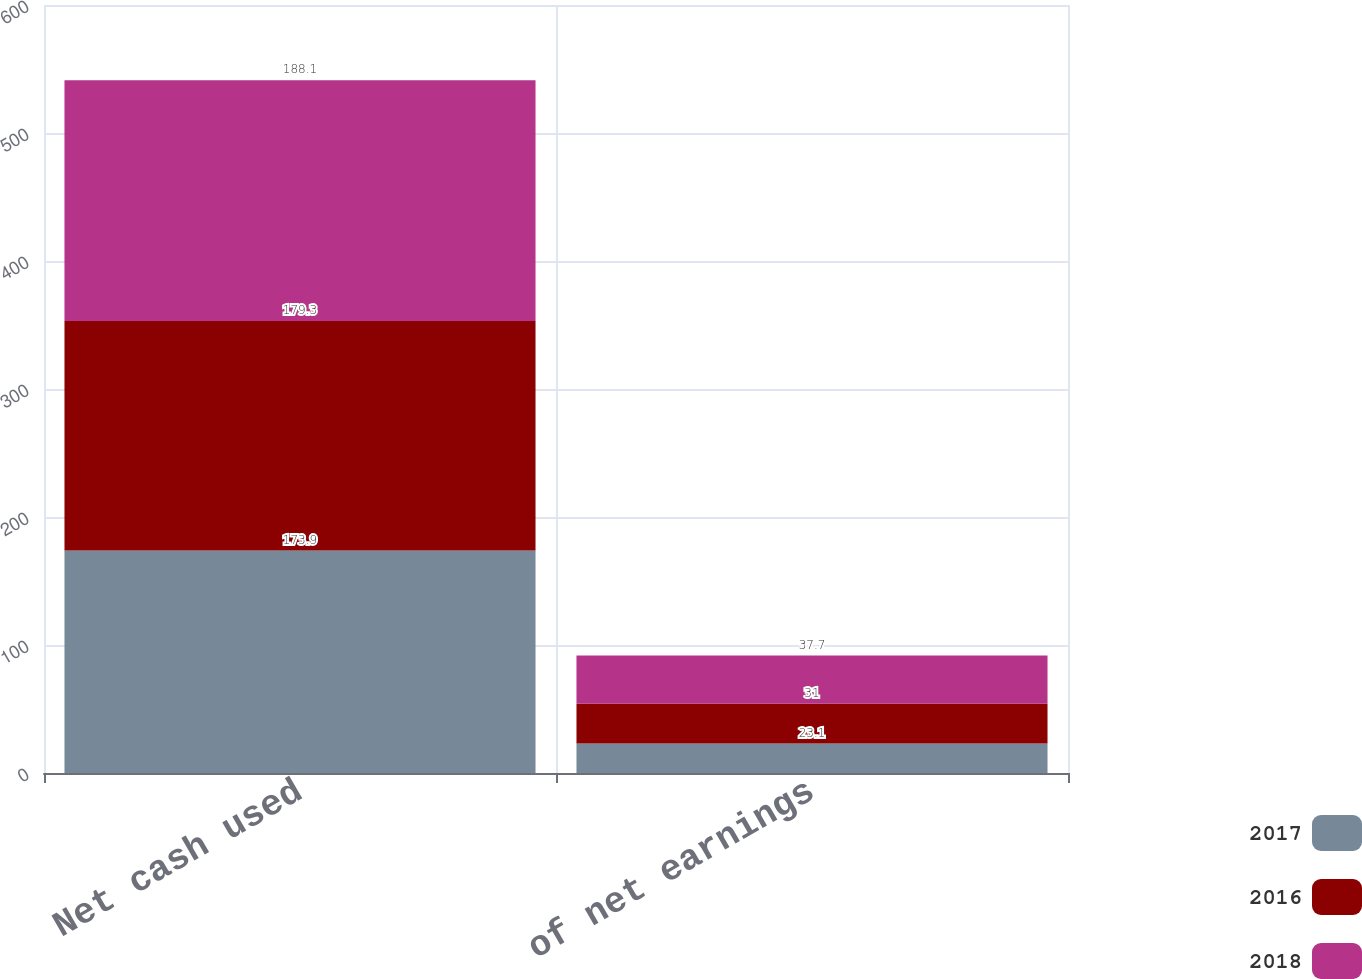Convert chart. <chart><loc_0><loc_0><loc_500><loc_500><stacked_bar_chart><ecel><fcel>Net cash used<fcel>of net earnings<nl><fcel>2017<fcel>173.9<fcel>23.1<nl><fcel>2016<fcel>179.3<fcel>31<nl><fcel>2018<fcel>188.1<fcel>37.7<nl></chart> 